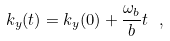Convert formula to latex. <formula><loc_0><loc_0><loc_500><loc_500>k _ { y } ( t ) = k _ { y } ( 0 ) + { \frac { \omega _ { b } } { b } } t \ ,</formula> 